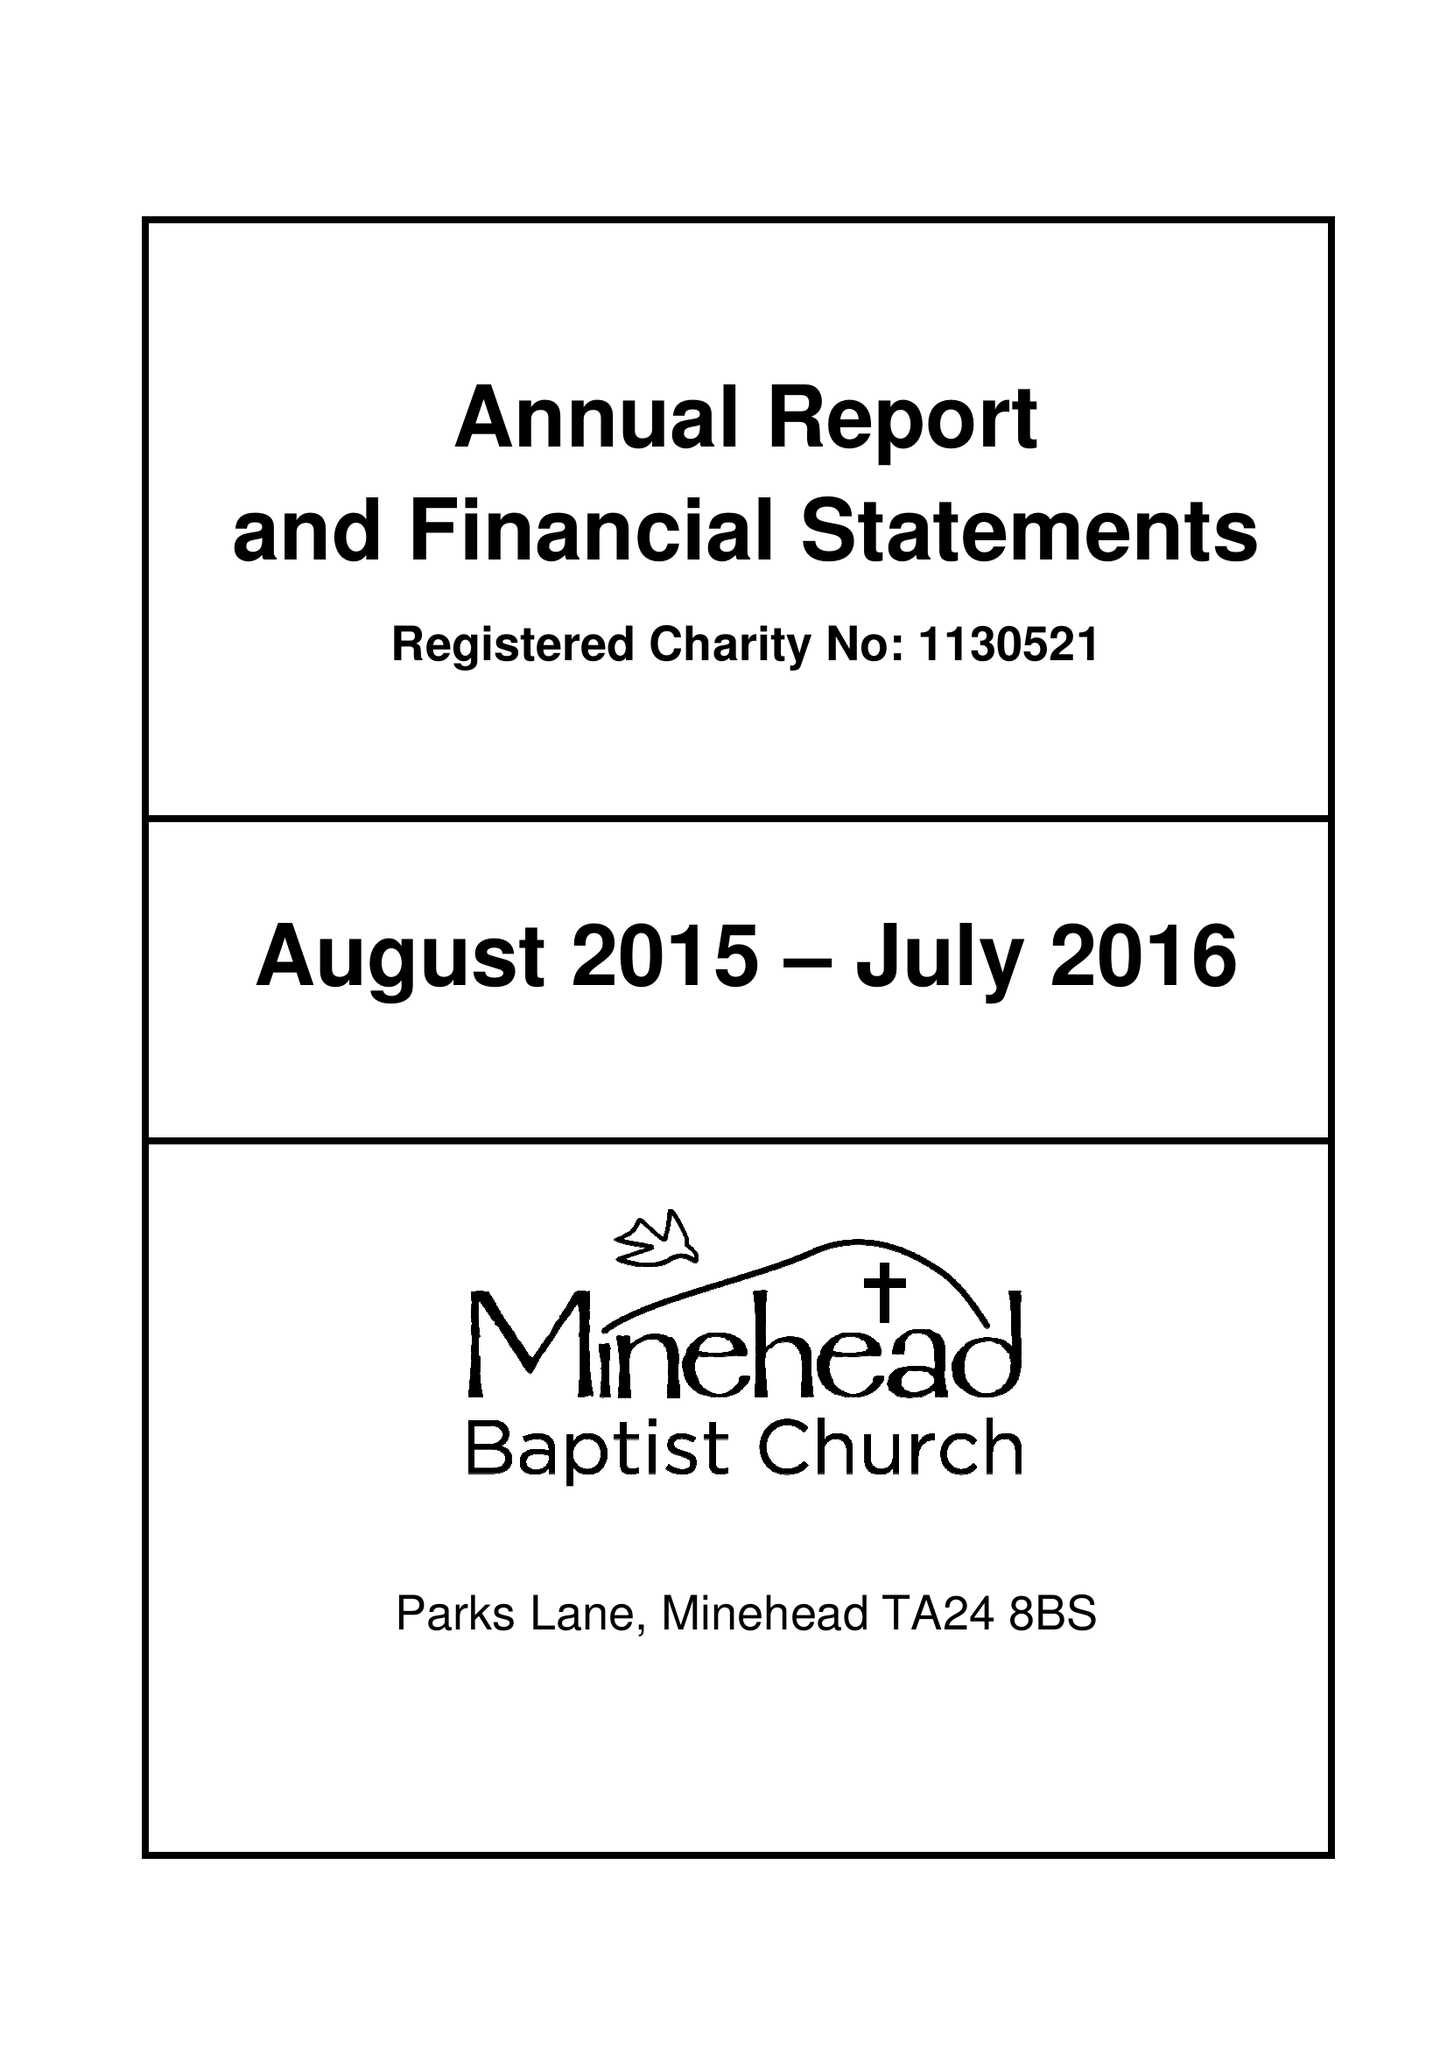What is the value for the report_date?
Answer the question using a single word or phrase. 2016-07-31 